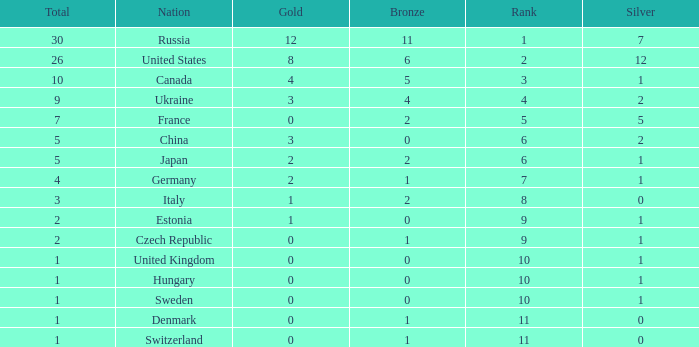What is the largest silver with Gold larger than 4, a Nation of united states, and a Total larger than 26? None. 